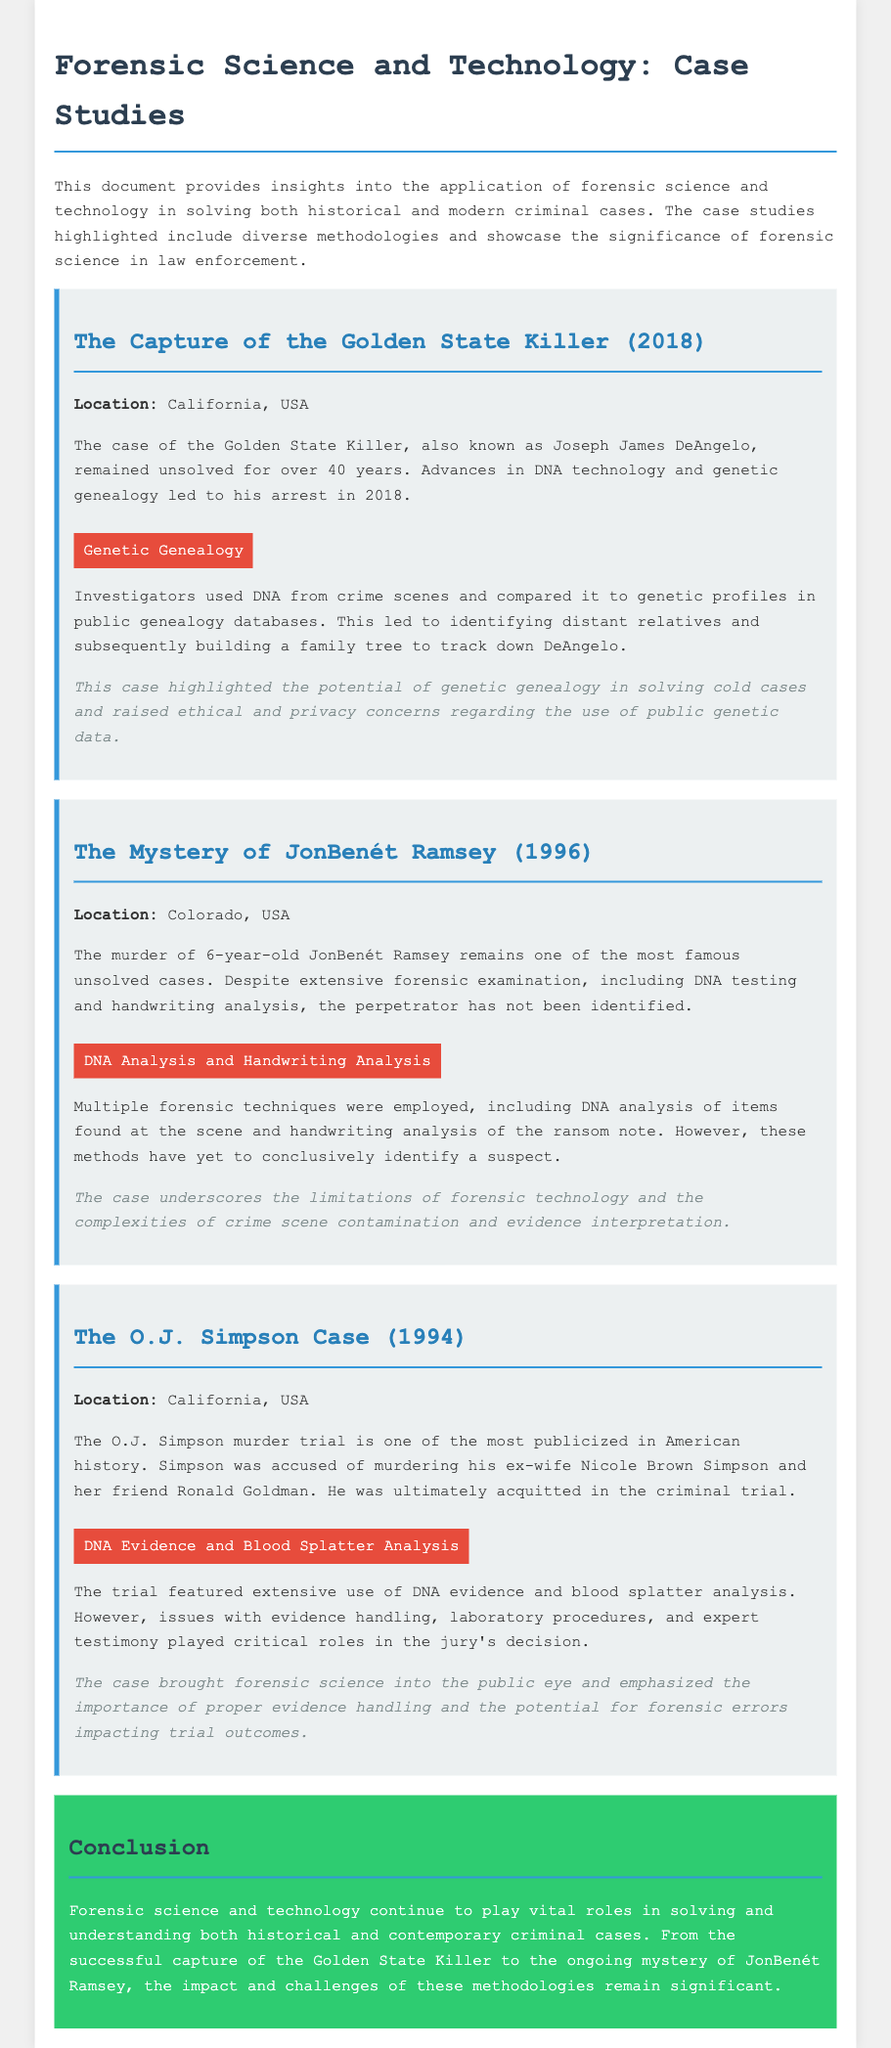What is the name of the Golden State Killer? The document refers to him as Joseph James DeAngelo, who was arrested in 2018.
Answer: Joseph James DeAngelo What forensic technique was used in the Golden State Killer case? Investigators utilized Genetic Genealogy to match DNA from crime scenes with public genealogy databases.
Answer: Genetic Genealogy In what year did the mystery of JonBenét Ramsey occur? The document states that her murder happened in 1996.
Answer: 1996 What type of analysis was performed on blood evidence in the O.J. Simpson case? The trial featured Blood Splatter Analysis in addition to DNA evidence.
Answer: Blood Splatter Analysis What is one impact highlighted in the JonBenét Ramsey case? It emphasizes the limitations of forensic technology and the complexities of crime scene evidence.
Answer: Limitations of forensic technology What is the main theme of the conclusion? The conclusion summarizes the ongoing significance and challenges of forensic science in solving criminal cases.
Answer: Significance of forensic science What was a critical issue in the O.J. Simpson trial? The document mentions issues with evidence handling and laboratory procedures as critical factors.
Answer: Evidence handling What is the location of the Golden State Killer case? The case is set in California, USA.
Answer: California, USA What type of evidence was used extensively in the O.J. Simpson trial? DNA Evidence was a significant part of the trial alongside blood analysis.
Answer: DNA Evidence 